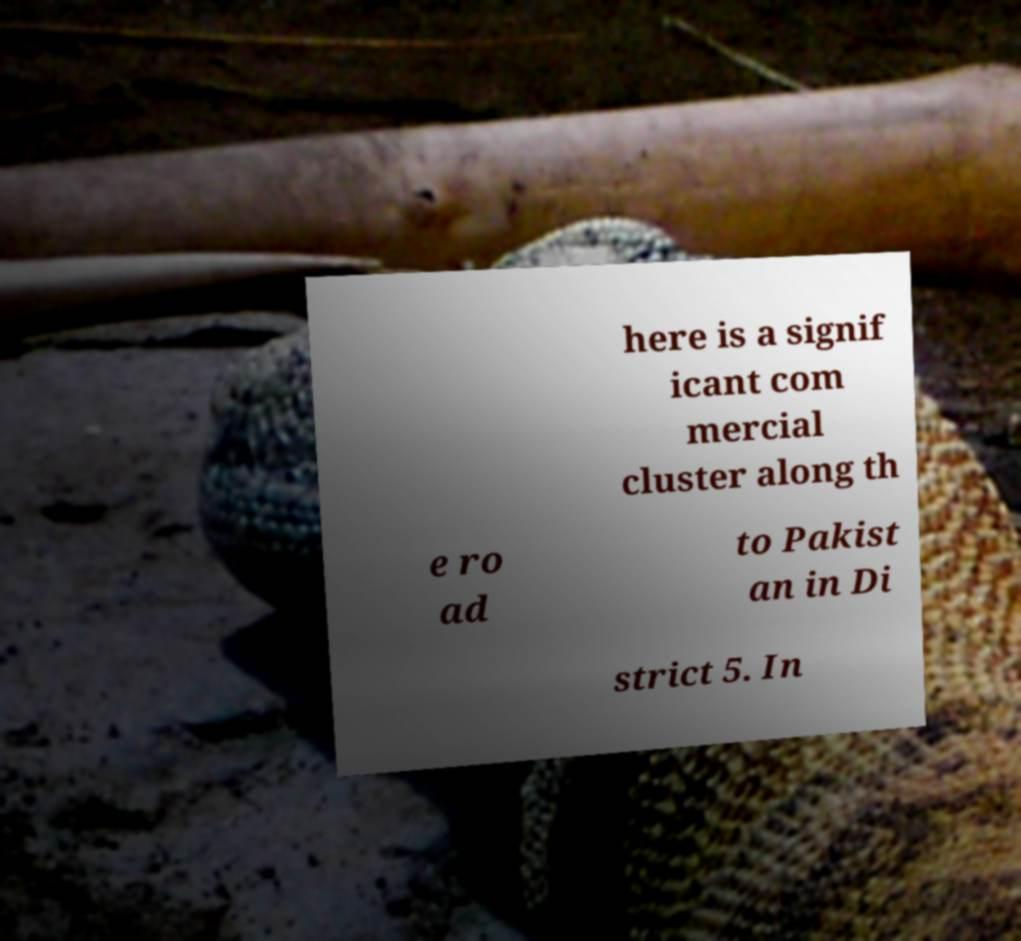Can you accurately transcribe the text from the provided image for me? here is a signif icant com mercial cluster along th e ro ad to Pakist an in Di strict 5. In 